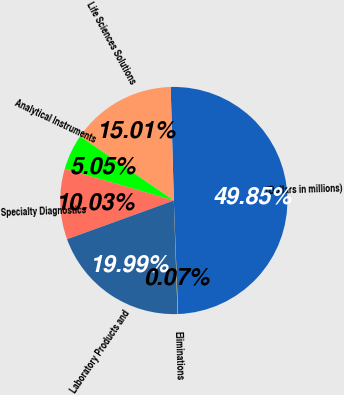Convert chart. <chart><loc_0><loc_0><loc_500><loc_500><pie_chart><fcel>(Dollars in millions)<fcel>Life Sciences Solutions<fcel>Analytical Instruments<fcel>Specialty Diagnostics<fcel>Laboratory Products and<fcel>Eliminations<nl><fcel>49.85%<fcel>15.01%<fcel>5.05%<fcel>10.03%<fcel>19.99%<fcel>0.07%<nl></chart> 